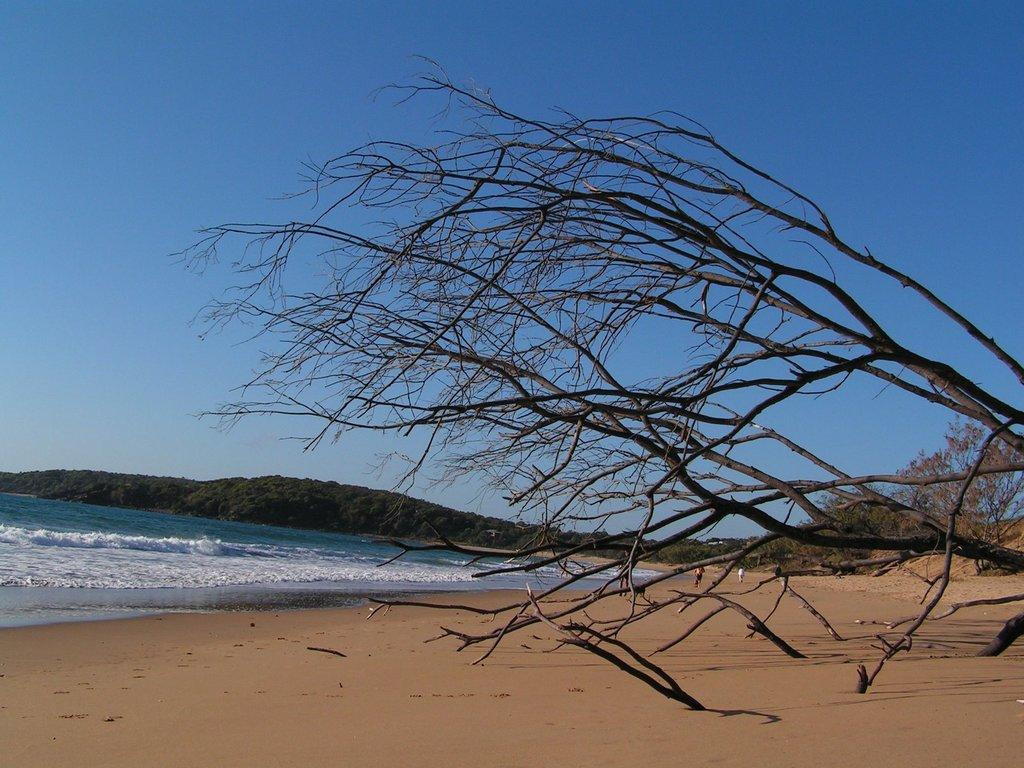What types of natural elements can be seen on the right side of the image? There are trees and sand on the right side of the image. What geographical features are located in the center of the image? There are hills and a water body in the center of the image. How would you describe the weather in the image? The sky is sunny in the image. What type of dress is the oil wearing in the image? There is no oil or dress present in the image. 